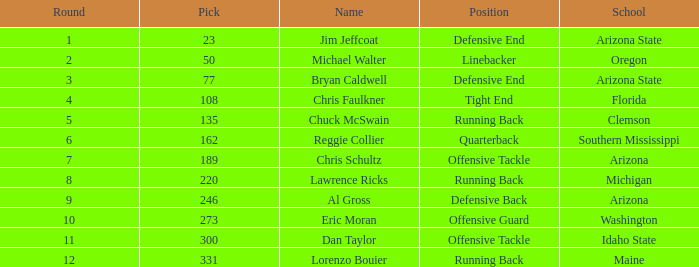What is the largest option in round 8? 220.0. 